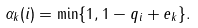<formula> <loc_0><loc_0><loc_500><loc_500>\alpha _ { k } ( i ) = \min \{ 1 , 1 - q _ { i } + e _ { k } \} .</formula> 